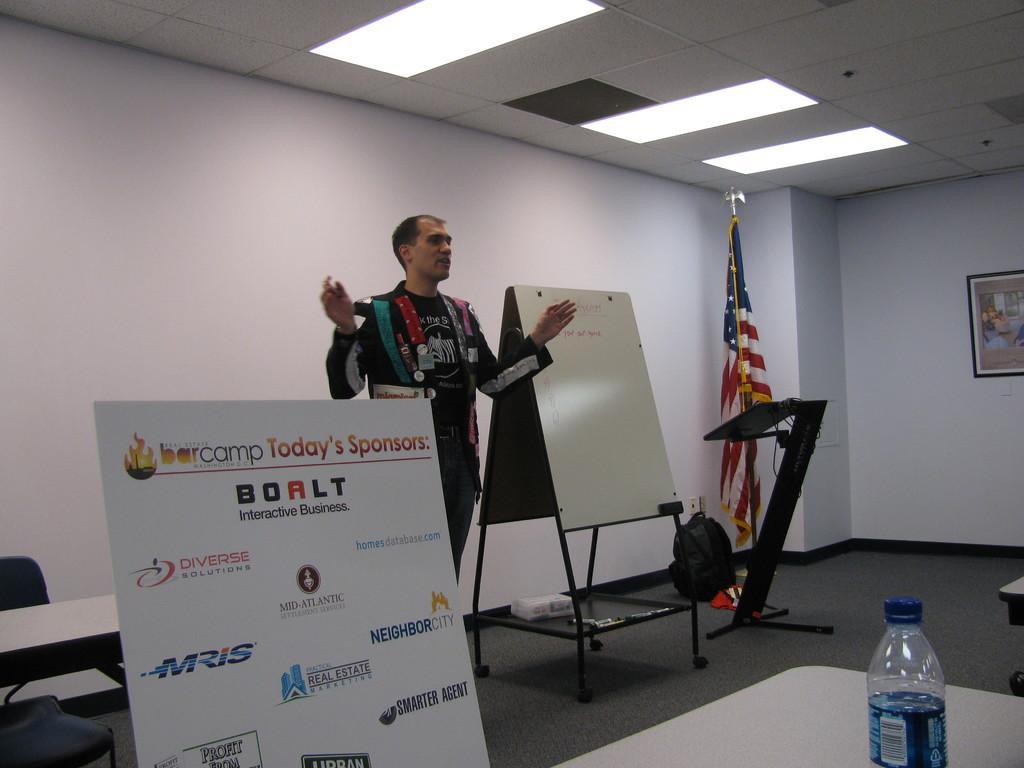In one or two sentences, can you explain what this image depicts? In this image I can see a man is standing. Here I can see a board and a flag. 